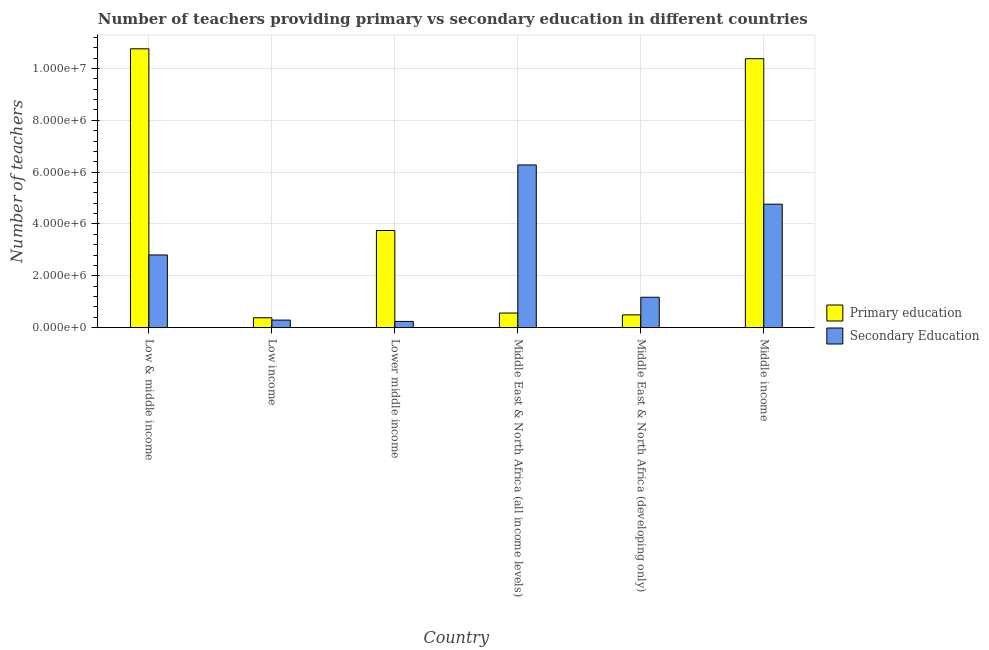How many different coloured bars are there?
Give a very brief answer. 2. How many groups of bars are there?
Make the answer very short. 6. Are the number of bars per tick equal to the number of legend labels?
Your response must be concise. Yes. Are the number of bars on each tick of the X-axis equal?
Offer a very short reply. Yes. How many bars are there on the 5th tick from the left?
Your answer should be compact. 2. What is the label of the 4th group of bars from the left?
Ensure brevity in your answer.  Middle East & North Africa (all income levels). What is the number of secondary teachers in Middle East & North Africa (all income levels)?
Provide a short and direct response. 6.28e+06. Across all countries, what is the maximum number of primary teachers?
Offer a very short reply. 1.08e+07. Across all countries, what is the minimum number of primary teachers?
Give a very brief answer. 3.81e+05. In which country was the number of secondary teachers maximum?
Your answer should be very brief. Middle East & North Africa (all income levels). What is the total number of primary teachers in the graph?
Offer a very short reply. 2.63e+07. What is the difference between the number of primary teachers in Middle East & North Africa (all income levels) and that in Middle East & North Africa (developing only)?
Offer a terse response. 7.06e+04. What is the difference between the number of secondary teachers in Middle income and the number of primary teachers in Middle East & North Africa (all income levels)?
Offer a terse response. 4.20e+06. What is the average number of primary teachers per country?
Ensure brevity in your answer.  4.39e+06. What is the difference between the number of primary teachers and number of secondary teachers in Low & middle income?
Provide a short and direct response. 7.95e+06. In how many countries, is the number of secondary teachers greater than 9600000 ?
Keep it short and to the point. 0. What is the ratio of the number of primary teachers in Low & middle income to that in Middle East & North Africa (all income levels)?
Offer a very short reply. 19.08. Is the difference between the number of primary teachers in Middle East & North Africa (all income levels) and Middle East & North Africa (developing only) greater than the difference between the number of secondary teachers in Middle East & North Africa (all income levels) and Middle East & North Africa (developing only)?
Offer a very short reply. No. What is the difference between the highest and the second highest number of secondary teachers?
Keep it short and to the point. 1.51e+06. What is the difference between the highest and the lowest number of secondary teachers?
Offer a very short reply. 6.04e+06. In how many countries, is the number of primary teachers greater than the average number of primary teachers taken over all countries?
Provide a short and direct response. 2. Is the sum of the number of secondary teachers in Low & middle income and Middle income greater than the maximum number of primary teachers across all countries?
Offer a terse response. No. What does the 2nd bar from the left in Middle East & North Africa (all income levels) represents?
Your answer should be very brief. Secondary Education. What does the 2nd bar from the right in Lower middle income represents?
Ensure brevity in your answer.  Primary education. Are all the bars in the graph horizontal?
Offer a terse response. No. How many countries are there in the graph?
Provide a succinct answer. 6. What is the difference between two consecutive major ticks on the Y-axis?
Offer a very short reply. 2.00e+06. Are the values on the major ticks of Y-axis written in scientific E-notation?
Your answer should be compact. Yes. Does the graph contain any zero values?
Your response must be concise. No. Does the graph contain grids?
Your answer should be very brief. Yes. What is the title of the graph?
Ensure brevity in your answer.  Number of teachers providing primary vs secondary education in different countries. Does "Fertility rate" appear as one of the legend labels in the graph?
Give a very brief answer. No. What is the label or title of the Y-axis?
Offer a terse response. Number of teachers. What is the Number of teachers of Primary education in Low & middle income?
Give a very brief answer. 1.08e+07. What is the Number of teachers in Secondary Education in Low & middle income?
Offer a very short reply. 2.81e+06. What is the Number of teachers of Primary education in Low income?
Offer a terse response. 3.81e+05. What is the Number of teachers of Secondary Education in Low income?
Your response must be concise. 2.92e+05. What is the Number of teachers in Primary education in Lower middle income?
Your answer should be very brief. 3.75e+06. What is the Number of teachers in Secondary Education in Lower middle income?
Provide a succinct answer. 2.41e+05. What is the Number of teachers in Primary education in Middle East & North Africa (all income levels)?
Offer a very short reply. 5.64e+05. What is the Number of teachers of Secondary Education in Middle East & North Africa (all income levels)?
Give a very brief answer. 6.28e+06. What is the Number of teachers in Primary education in Middle East & North Africa (developing only)?
Keep it short and to the point. 4.93e+05. What is the Number of teachers in Secondary Education in Middle East & North Africa (developing only)?
Keep it short and to the point. 1.17e+06. What is the Number of teachers of Primary education in Middle income?
Your answer should be compact. 1.04e+07. What is the Number of teachers in Secondary Education in Middle income?
Your answer should be compact. 4.76e+06. Across all countries, what is the maximum Number of teachers of Primary education?
Your response must be concise. 1.08e+07. Across all countries, what is the maximum Number of teachers of Secondary Education?
Your response must be concise. 6.28e+06. Across all countries, what is the minimum Number of teachers in Primary education?
Provide a short and direct response. 3.81e+05. Across all countries, what is the minimum Number of teachers in Secondary Education?
Your answer should be very brief. 2.41e+05. What is the total Number of teachers in Primary education in the graph?
Provide a short and direct response. 2.63e+07. What is the total Number of teachers in Secondary Education in the graph?
Offer a terse response. 1.56e+07. What is the difference between the Number of teachers in Primary education in Low & middle income and that in Low income?
Your response must be concise. 1.04e+07. What is the difference between the Number of teachers of Secondary Education in Low & middle income and that in Low income?
Ensure brevity in your answer.  2.51e+06. What is the difference between the Number of teachers in Primary education in Low & middle income and that in Lower middle income?
Offer a very short reply. 7.01e+06. What is the difference between the Number of teachers of Secondary Education in Low & middle income and that in Lower middle income?
Give a very brief answer. 2.56e+06. What is the difference between the Number of teachers in Primary education in Low & middle income and that in Middle East & North Africa (all income levels)?
Give a very brief answer. 1.02e+07. What is the difference between the Number of teachers of Secondary Education in Low & middle income and that in Middle East & North Africa (all income levels)?
Keep it short and to the point. -3.47e+06. What is the difference between the Number of teachers in Primary education in Low & middle income and that in Middle East & North Africa (developing only)?
Your answer should be compact. 1.03e+07. What is the difference between the Number of teachers in Secondary Education in Low & middle income and that in Middle East & North Africa (developing only)?
Your answer should be compact. 1.63e+06. What is the difference between the Number of teachers of Primary education in Low & middle income and that in Middle income?
Ensure brevity in your answer.  3.81e+05. What is the difference between the Number of teachers of Secondary Education in Low & middle income and that in Middle income?
Provide a succinct answer. -1.96e+06. What is the difference between the Number of teachers of Primary education in Low income and that in Lower middle income?
Your answer should be compact. -3.37e+06. What is the difference between the Number of teachers in Secondary Education in Low income and that in Lower middle income?
Ensure brevity in your answer.  5.16e+04. What is the difference between the Number of teachers of Primary education in Low income and that in Middle East & North Africa (all income levels)?
Offer a terse response. -1.82e+05. What is the difference between the Number of teachers in Secondary Education in Low income and that in Middle East & North Africa (all income levels)?
Your response must be concise. -5.99e+06. What is the difference between the Number of teachers of Primary education in Low income and that in Middle East & North Africa (developing only)?
Your answer should be very brief. -1.12e+05. What is the difference between the Number of teachers in Secondary Education in Low income and that in Middle East & North Africa (developing only)?
Your response must be concise. -8.81e+05. What is the difference between the Number of teachers of Primary education in Low income and that in Middle income?
Your response must be concise. -9.99e+06. What is the difference between the Number of teachers of Secondary Education in Low income and that in Middle income?
Keep it short and to the point. -4.47e+06. What is the difference between the Number of teachers of Primary education in Lower middle income and that in Middle East & North Africa (all income levels)?
Provide a succinct answer. 3.18e+06. What is the difference between the Number of teachers in Secondary Education in Lower middle income and that in Middle East & North Africa (all income levels)?
Your response must be concise. -6.04e+06. What is the difference between the Number of teachers in Primary education in Lower middle income and that in Middle East & North Africa (developing only)?
Provide a succinct answer. 3.25e+06. What is the difference between the Number of teachers in Secondary Education in Lower middle income and that in Middle East & North Africa (developing only)?
Your answer should be very brief. -9.32e+05. What is the difference between the Number of teachers in Primary education in Lower middle income and that in Middle income?
Offer a terse response. -6.63e+06. What is the difference between the Number of teachers of Secondary Education in Lower middle income and that in Middle income?
Give a very brief answer. -4.52e+06. What is the difference between the Number of teachers of Primary education in Middle East & North Africa (all income levels) and that in Middle East & North Africa (developing only)?
Provide a short and direct response. 7.06e+04. What is the difference between the Number of teachers in Secondary Education in Middle East & North Africa (all income levels) and that in Middle East & North Africa (developing only)?
Offer a very short reply. 5.10e+06. What is the difference between the Number of teachers of Primary education in Middle East & North Africa (all income levels) and that in Middle income?
Make the answer very short. -9.81e+06. What is the difference between the Number of teachers in Secondary Education in Middle East & North Africa (all income levels) and that in Middle income?
Give a very brief answer. 1.51e+06. What is the difference between the Number of teachers of Primary education in Middle East & North Africa (developing only) and that in Middle income?
Offer a terse response. -9.88e+06. What is the difference between the Number of teachers in Secondary Education in Middle East & North Africa (developing only) and that in Middle income?
Offer a terse response. -3.59e+06. What is the difference between the Number of teachers in Primary education in Low & middle income and the Number of teachers in Secondary Education in Low income?
Ensure brevity in your answer.  1.05e+07. What is the difference between the Number of teachers in Primary education in Low & middle income and the Number of teachers in Secondary Education in Lower middle income?
Your response must be concise. 1.05e+07. What is the difference between the Number of teachers of Primary education in Low & middle income and the Number of teachers of Secondary Education in Middle East & North Africa (all income levels)?
Offer a very short reply. 4.48e+06. What is the difference between the Number of teachers in Primary education in Low & middle income and the Number of teachers in Secondary Education in Middle East & North Africa (developing only)?
Your response must be concise. 9.58e+06. What is the difference between the Number of teachers in Primary education in Low & middle income and the Number of teachers in Secondary Education in Middle income?
Offer a terse response. 5.99e+06. What is the difference between the Number of teachers in Primary education in Low income and the Number of teachers in Secondary Education in Lower middle income?
Keep it short and to the point. 1.41e+05. What is the difference between the Number of teachers in Primary education in Low income and the Number of teachers in Secondary Education in Middle East & North Africa (all income levels)?
Your response must be concise. -5.90e+06. What is the difference between the Number of teachers in Primary education in Low income and the Number of teachers in Secondary Education in Middle East & North Africa (developing only)?
Offer a terse response. -7.92e+05. What is the difference between the Number of teachers in Primary education in Low income and the Number of teachers in Secondary Education in Middle income?
Make the answer very short. -4.38e+06. What is the difference between the Number of teachers of Primary education in Lower middle income and the Number of teachers of Secondary Education in Middle East & North Africa (all income levels)?
Make the answer very short. -2.53e+06. What is the difference between the Number of teachers of Primary education in Lower middle income and the Number of teachers of Secondary Education in Middle East & North Africa (developing only)?
Your answer should be very brief. 2.57e+06. What is the difference between the Number of teachers in Primary education in Lower middle income and the Number of teachers in Secondary Education in Middle income?
Ensure brevity in your answer.  -1.02e+06. What is the difference between the Number of teachers of Primary education in Middle East & North Africa (all income levels) and the Number of teachers of Secondary Education in Middle East & North Africa (developing only)?
Your response must be concise. -6.09e+05. What is the difference between the Number of teachers in Primary education in Middle East & North Africa (all income levels) and the Number of teachers in Secondary Education in Middle income?
Offer a very short reply. -4.20e+06. What is the difference between the Number of teachers of Primary education in Middle East & North Africa (developing only) and the Number of teachers of Secondary Education in Middle income?
Make the answer very short. -4.27e+06. What is the average Number of teachers in Primary education per country?
Keep it short and to the point. 4.39e+06. What is the average Number of teachers in Secondary Education per country?
Your answer should be very brief. 2.59e+06. What is the difference between the Number of teachers of Primary education and Number of teachers of Secondary Education in Low & middle income?
Keep it short and to the point. 7.95e+06. What is the difference between the Number of teachers of Primary education and Number of teachers of Secondary Education in Low income?
Your response must be concise. 8.91e+04. What is the difference between the Number of teachers in Primary education and Number of teachers in Secondary Education in Lower middle income?
Offer a very short reply. 3.51e+06. What is the difference between the Number of teachers in Primary education and Number of teachers in Secondary Education in Middle East & North Africa (all income levels)?
Make the answer very short. -5.71e+06. What is the difference between the Number of teachers of Primary education and Number of teachers of Secondary Education in Middle East & North Africa (developing only)?
Your answer should be compact. -6.80e+05. What is the difference between the Number of teachers of Primary education and Number of teachers of Secondary Education in Middle income?
Your response must be concise. 5.61e+06. What is the ratio of the Number of teachers in Primary education in Low & middle income to that in Low income?
Provide a short and direct response. 28.2. What is the ratio of the Number of teachers in Secondary Education in Low & middle income to that in Low income?
Offer a very short reply. 9.59. What is the ratio of the Number of teachers in Primary education in Low & middle income to that in Lower middle income?
Offer a very short reply. 2.87. What is the ratio of the Number of teachers in Secondary Education in Low & middle income to that in Lower middle income?
Your answer should be compact. 11.65. What is the ratio of the Number of teachers in Primary education in Low & middle income to that in Middle East & North Africa (all income levels)?
Offer a terse response. 19.08. What is the ratio of the Number of teachers of Secondary Education in Low & middle income to that in Middle East & North Africa (all income levels)?
Offer a terse response. 0.45. What is the ratio of the Number of teachers in Primary education in Low & middle income to that in Middle East & North Africa (developing only)?
Make the answer very short. 21.81. What is the ratio of the Number of teachers of Secondary Education in Low & middle income to that in Middle East & North Africa (developing only)?
Offer a terse response. 2.39. What is the ratio of the Number of teachers of Primary education in Low & middle income to that in Middle income?
Keep it short and to the point. 1.04. What is the ratio of the Number of teachers in Secondary Education in Low & middle income to that in Middle income?
Your response must be concise. 0.59. What is the ratio of the Number of teachers in Primary education in Low income to that in Lower middle income?
Your response must be concise. 0.1. What is the ratio of the Number of teachers in Secondary Education in Low income to that in Lower middle income?
Your response must be concise. 1.21. What is the ratio of the Number of teachers in Primary education in Low income to that in Middle East & North Africa (all income levels)?
Provide a succinct answer. 0.68. What is the ratio of the Number of teachers of Secondary Education in Low income to that in Middle East & North Africa (all income levels)?
Provide a succinct answer. 0.05. What is the ratio of the Number of teachers in Primary education in Low income to that in Middle East & North Africa (developing only)?
Make the answer very short. 0.77. What is the ratio of the Number of teachers in Secondary Education in Low income to that in Middle East & North Africa (developing only)?
Your response must be concise. 0.25. What is the ratio of the Number of teachers in Primary education in Low income to that in Middle income?
Provide a short and direct response. 0.04. What is the ratio of the Number of teachers in Secondary Education in Low income to that in Middle income?
Give a very brief answer. 0.06. What is the ratio of the Number of teachers of Primary education in Lower middle income to that in Middle East & North Africa (all income levels)?
Provide a short and direct response. 6.65. What is the ratio of the Number of teachers in Secondary Education in Lower middle income to that in Middle East & North Africa (all income levels)?
Your answer should be compact. 0.04. What is the ratio of the Number of teachers in Primary education in Lower middle income to that in Middle East & North Africa (developing only)?
Give a very brief answer. 7.6. What is the ratio of the Number of teachers in Secondary Education in Lower middle income to that in Middle East & North Africa (developing only)?
Make the answer very short. 0.21. What is the ratio of the Number of teachers of Primary education in Lower middle income to that in Middle income?
Ensure brevity in your answer.  0.36. What is the ratio of the Number of teachers of Secondary Education in Lower middle income to that in Middle income?
Ensure brevity in your answer.  0.05. What is the ratio of the Number of teachers of Primary education in Middle East & North Africa (all income levels) to that in Middle East & North Africa (developing only)?
Your response must be concise. 1.14. What is the ratio of the Number of teachers in Secondary Education in Middle East & North Africa (all income levels) to that in Middle East & North Africa (developing only)?
Offer a terse response. 5.35. What is the ratio of the Number of teachers of Primary education in Middle East & North Africa (all income levels) to that in Middle income?
Offer a very short reply. 0.05. What is the ratio of the Number of teachers in Secondary Education in Middle East & North Africa (all income levels) to that in Middle income?
Make the answer very short. 1.32. What is the ratio of the Number of teachers in Primary education in Middle East & North Africa (developing only) to that in Middle income?
Your response must be concise. 0.05. What is the ratio of the Number of teachers of Secondary Education in Middle East & North Africa (developing only) to that in Middle income?
Ensure brevity in your answer.  0.25. What is the difference between the highest and the second highest Number of teachers of Primary education?
Your answer should be compact. 3.81e+05. What is the difference between the highest and the second highest Number of teachers of Secondary Education?
Your answer should be compact. 1.51e+06. What is the difference between the highest and the lowest Number of teachers in Primary education?
Offer a terse response. 1.04e+07. What is the difference between the highest and the lowest Number of teachers of Secondary Education?
Provide a short and direct response. 6.04e+06. 